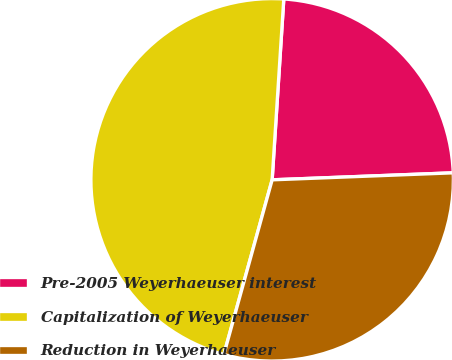Convert chart to OTSL. <chart><loc_0><loc_0><loc_500><loc_500><pie_chart><fcel>Pre-2005 Weyerhaeuser interest<fcel>Capitalization of Weyerhaeuser<fcel>Reduction in Weyerhaeuser<nl><fcel>23.36%<fcel>46.73%<fcel>29.91%<nl></chart> 